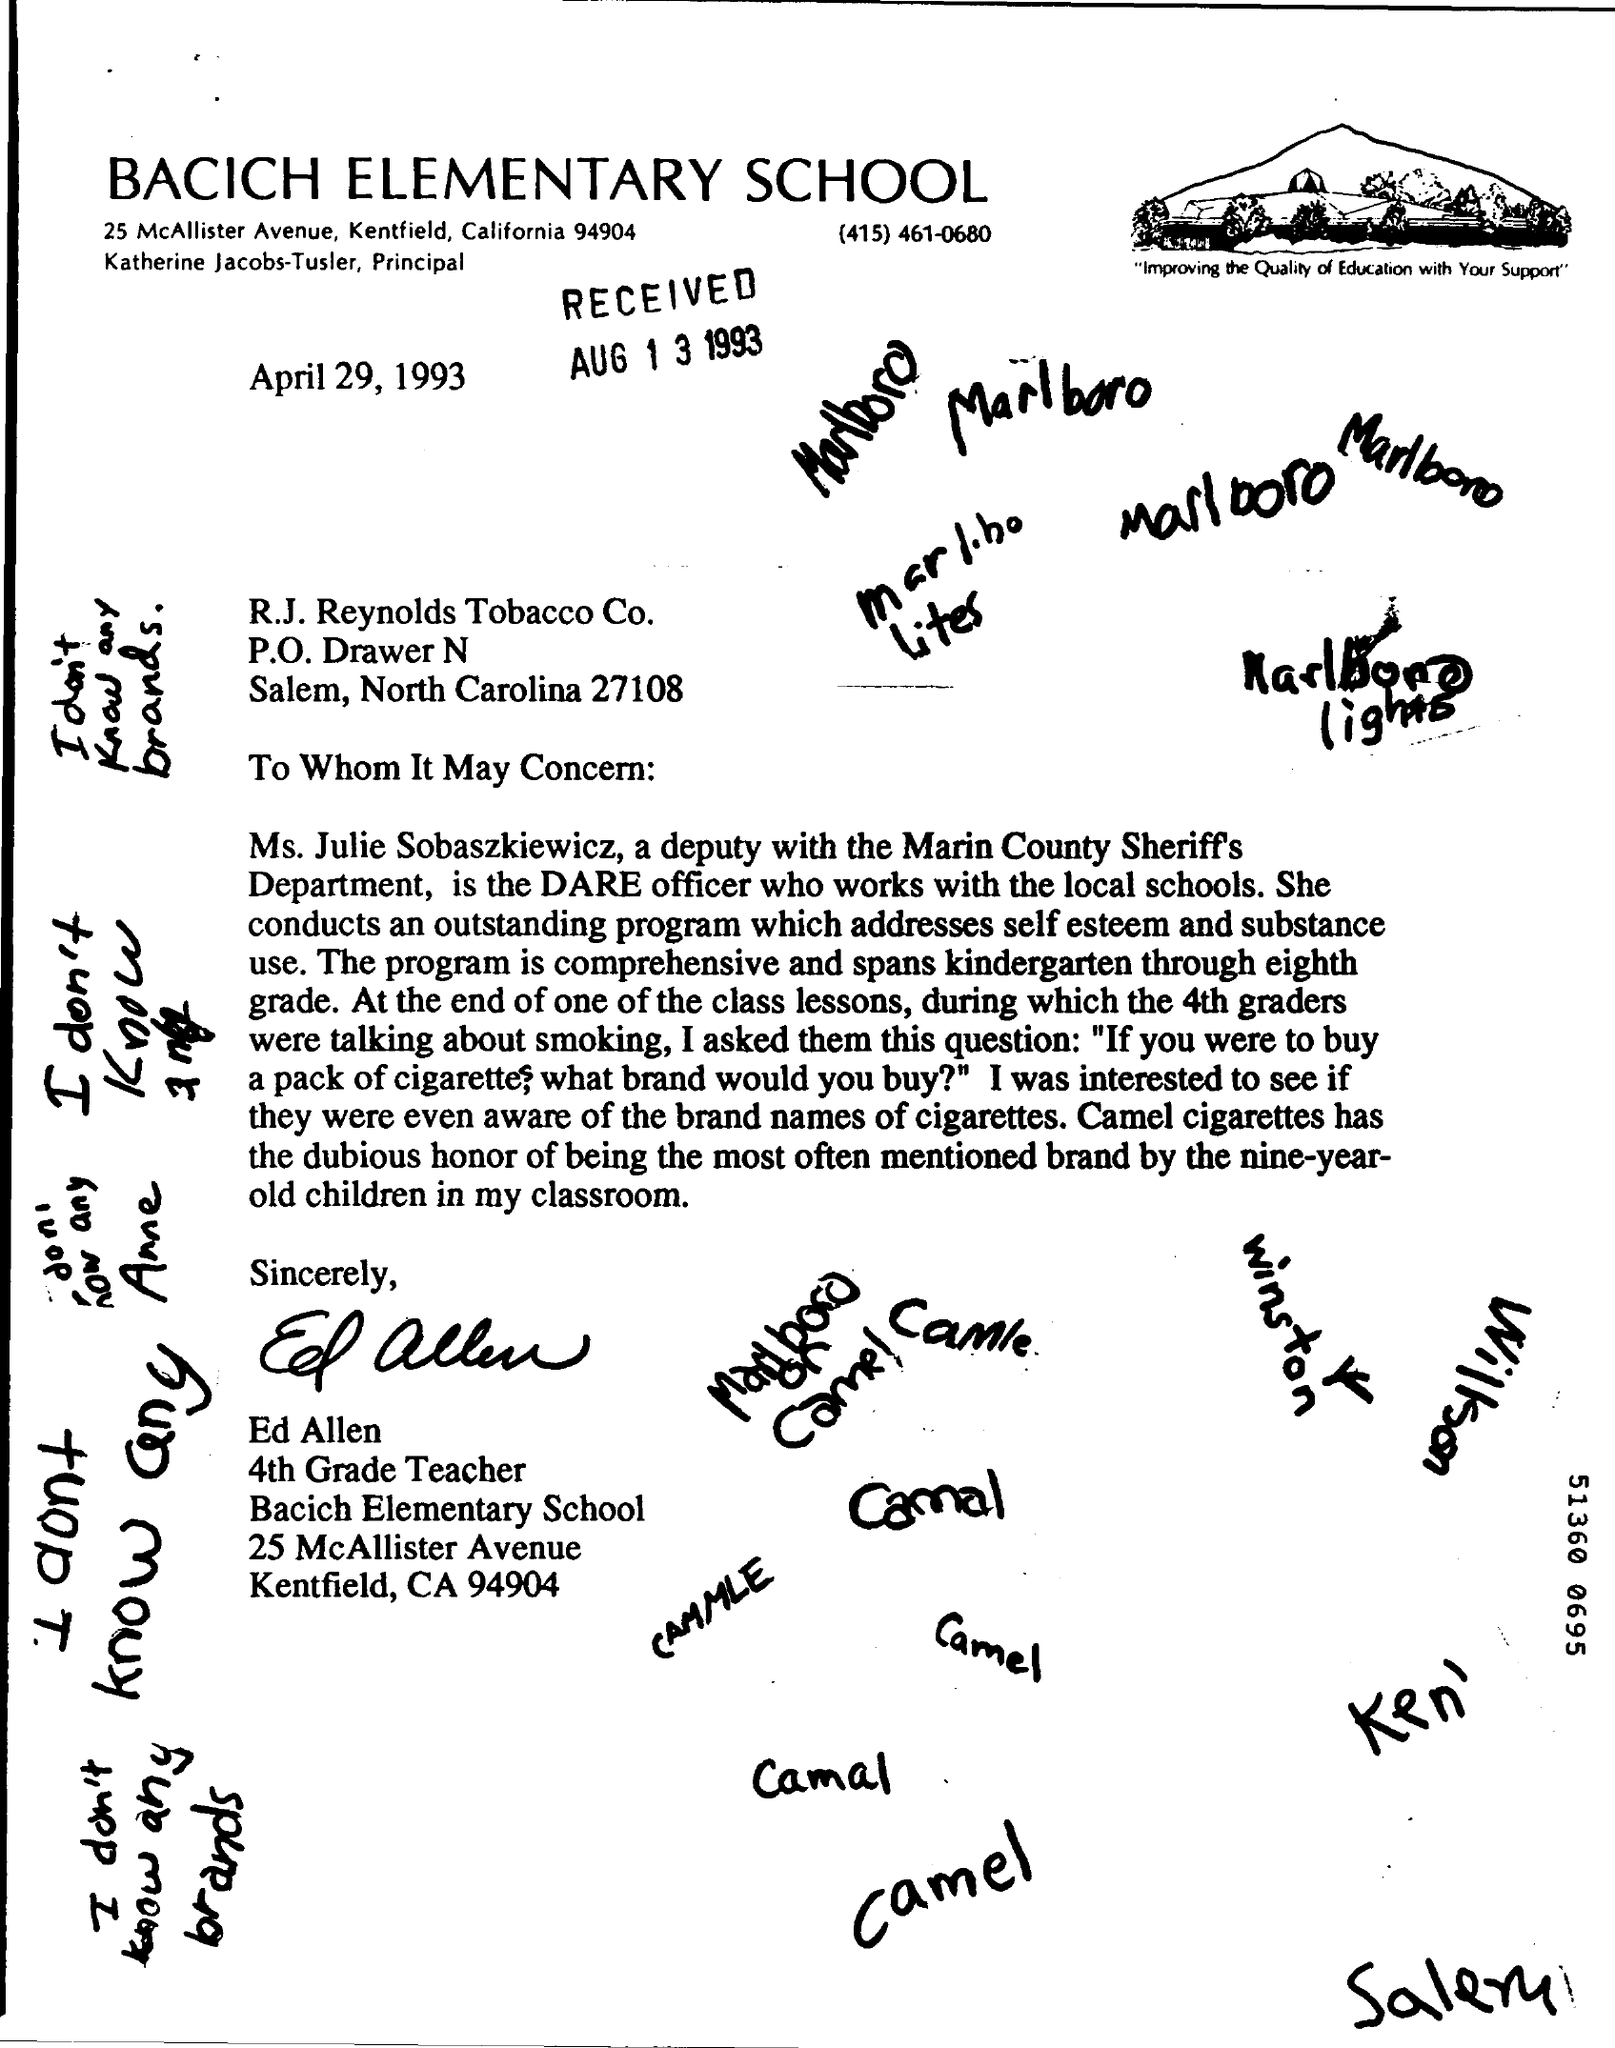What is the School Name ?
Offer a very short reply. BACICH ELEMENTARY SCHOOL. What is the date mentioned on the letter ?
Ensure brevity in your answer.  April 29, 1993. What is the RECEIVED Date ?
Offer a terse response. AUG 1 3 1993. 